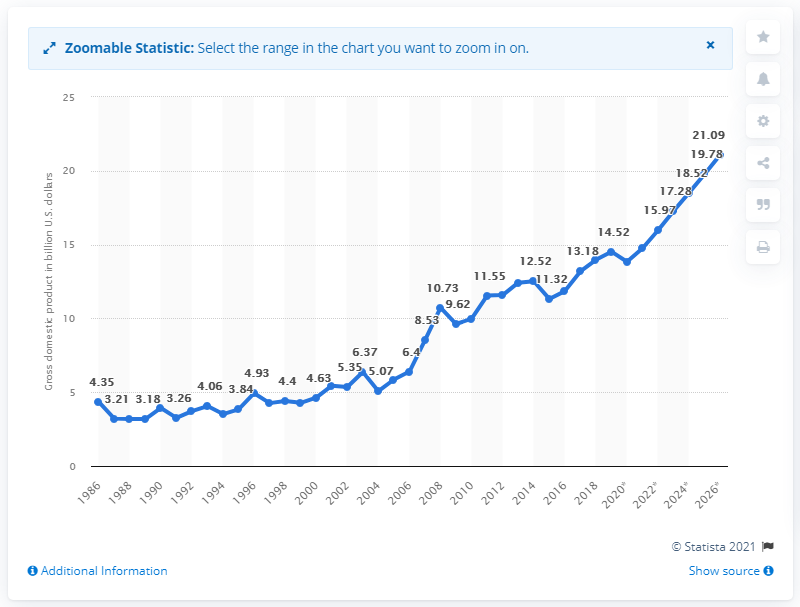Specify some key components in this picture. The gross domestic product of Madagascar in dollars in the year 2018 was 13.84. 